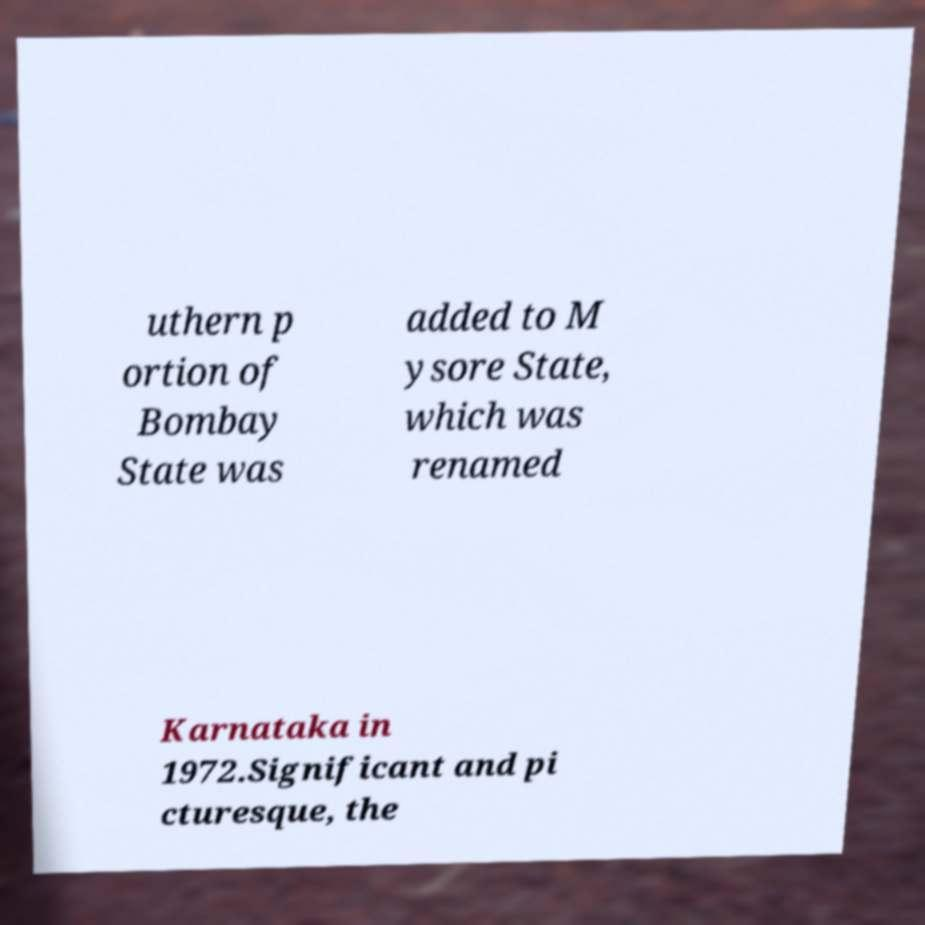Could you assist in decoding the text presented in this image and type it out clearly? uthern p ortion of Bombay State was added to M ysore State, which was renamed Karnataka in 1972.Significant and pi cturesque, the 